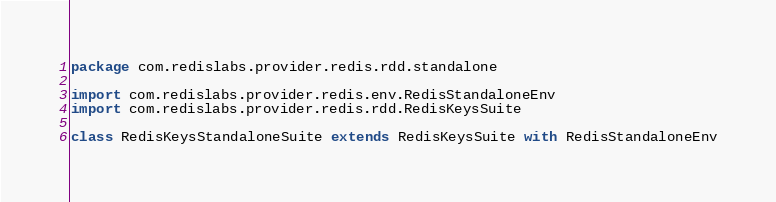Convert code to text. <code><loc_0><loc_0><loc_500><loc_500><_Scala_>package com.redislabs.provider.redis.rdd.standalone

import com.redislabs.provider.redis.env.RedisStandaloneEnv
import com.redislabs.provider.redis.rdd.RedisKeysSuite

class RedisKeysStandaloneSuite extends RedisKeysSuite with RedisStandaloneEnv
</code> 